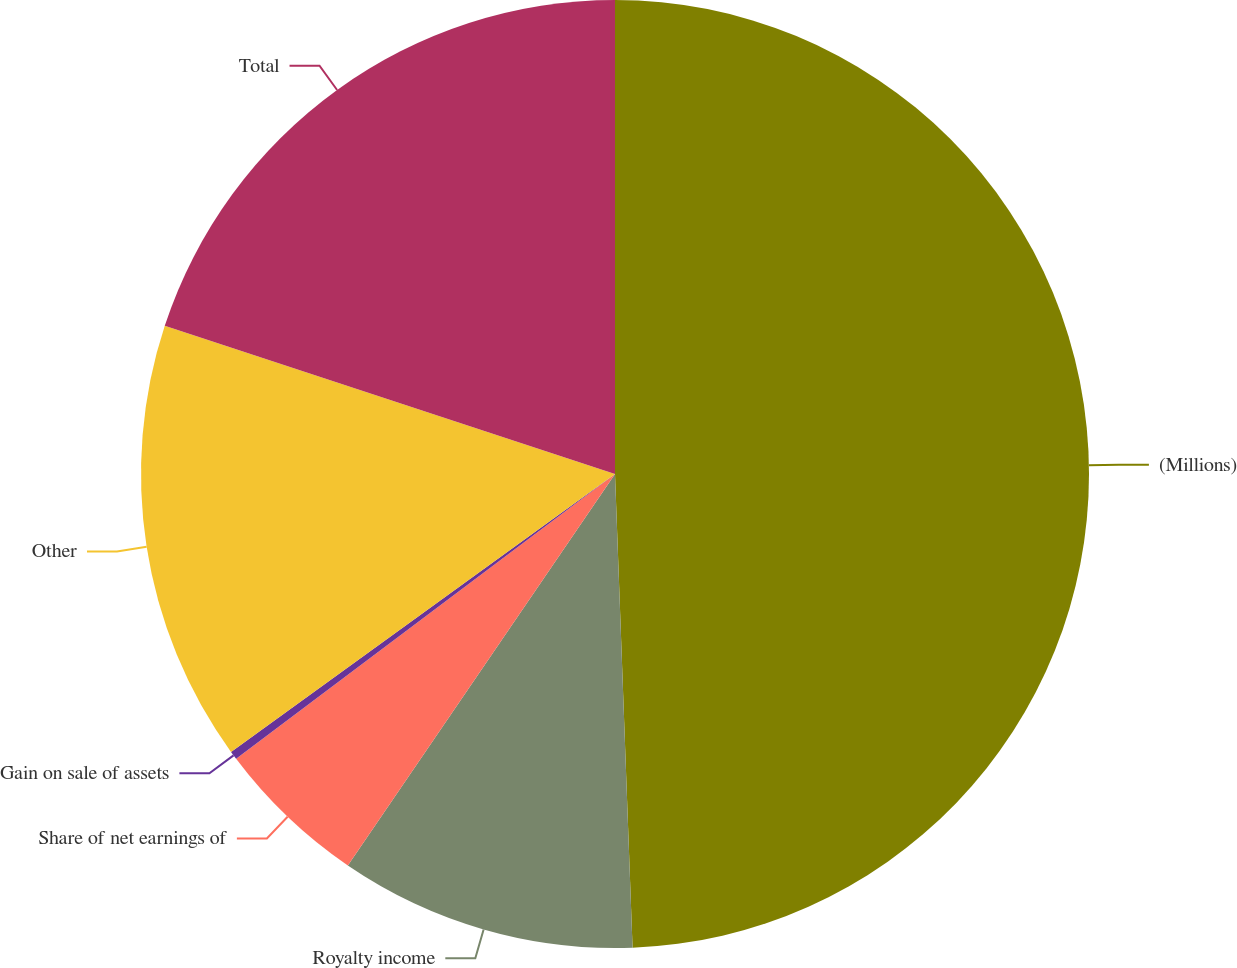Convert chart to OTSL. <chart><loc_0><loc_0><loc_500><loc_500><pie_chart><fcel>(Millions)<fcel>Royalty income<fcel>Share of net earnings of<fcel>Gain on sale of assets<fcel>Other<fcel>Total<nl><fcel>49.41%<fcel>10.12%<fcel>5.21%<fcel>0.29%<fcel>15.03%<fcel>19.94%<nl></chart> 